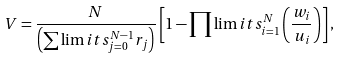Convert formula to latex. <formula><loc_0><loc_0><loc_500><loc_500>V = \frac { N } { \left ( \sum \lim i t s _ { j = 0 } ^ { N - 1 } r _ { j } \right ) } \left [ 1 - \prod \lim i t s _ { i = 1 } ^ { N } \left ( \frac { w _ { i } } { u _ { i } } \right ) \right ] ,</formula> 